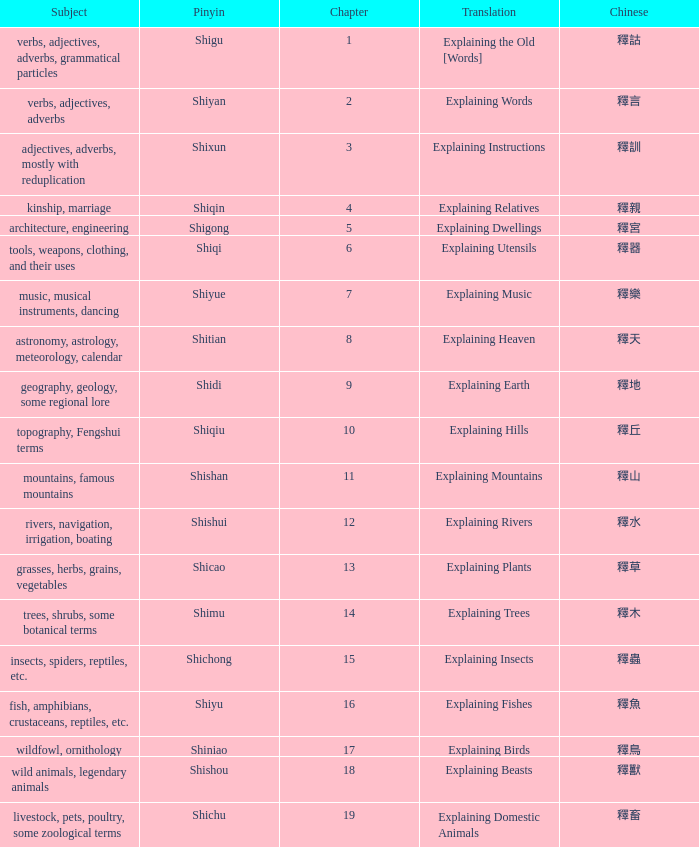Give me the full table as a dictionary. {'header': ['Subject', 'Pinyin', 'Chapter', 'Translation', 'Chinese'], 'rows': [['verbs, adjectives, adverbs, grammatical particles', 'Shigu', '1', 'Explaining the Old [Words]', '釋詁'], ['verbs, adjectives, adverbs', 'Shiyan', '2', 'Explaining Words', '釋言'], ['adjectives, adverbs, mostly with reduplication', 'Shixun', '3', 'Explaining Instructions', '釋訓'], ['kinship, marriage', 'Shiqin', '4', 'Explaining Relatives', '釋親'], ['architecture, engineering', 'Shigong', '5', 'Explaining Dwellings', '釋宮'], ['tools, weapons, clothing, and their uses', 'Shiqi', '6', 'Explaining Utensils', '釋器'], ['music, musical instruments, dancing', 'Shiyue', '7', 'Explaining Music', '釋樂'], ['astronomy, astrology, meteorology, calendar', 'Shitian', '8', 'Explaining Heaven', '釋天'], ['geography, geology, some regional lore', 'Shidi', '9', 'Explaining Earth', '釋地'], ['topography, Fengshui terms', 'Shiqiu', '10', 'Explaining Hills', '釋丘'], ['mountains, famous mountains', 'Shishan', '11', 'Explaining Mountains', '釋山'], ['rivers, navigation, irrigation, boating', 'Shishui', '12', 'Explaining Rivers', '釋水'], ['grasses, herbs, grains, vegetables', 'Shicao', '13', 'Explaining Plants', '釋草'], ['trees, shrubs, some botanical terms', 'Shimu', '14', 'Explaining Trees', '釋木'], ['insects, spiders, reptiles, etc.', 'Shichong', '15', 'Explaining Insects', '釋蟲'], ['fish, amphibians, crustaceans, reptiles, etc.', 'Shiyu', '16', 'Explaining Fishes', '釋魚'], ['wildfowl, ornithology', 'Shiniao', '17', 'Explaining Birds', '釋鳥'], ['wild animals, legendary animals', 'Shishou', '18', 'Explaining Beasts', '釋獸'], ['livestock, pets, poultry, some zoological terms', 'Shichu', '19', 'Explaining Domestic Animals', '釋畜']]} Name the chinese with subject of adjectives, adverbs, mostly with reduplication 釋訓. 